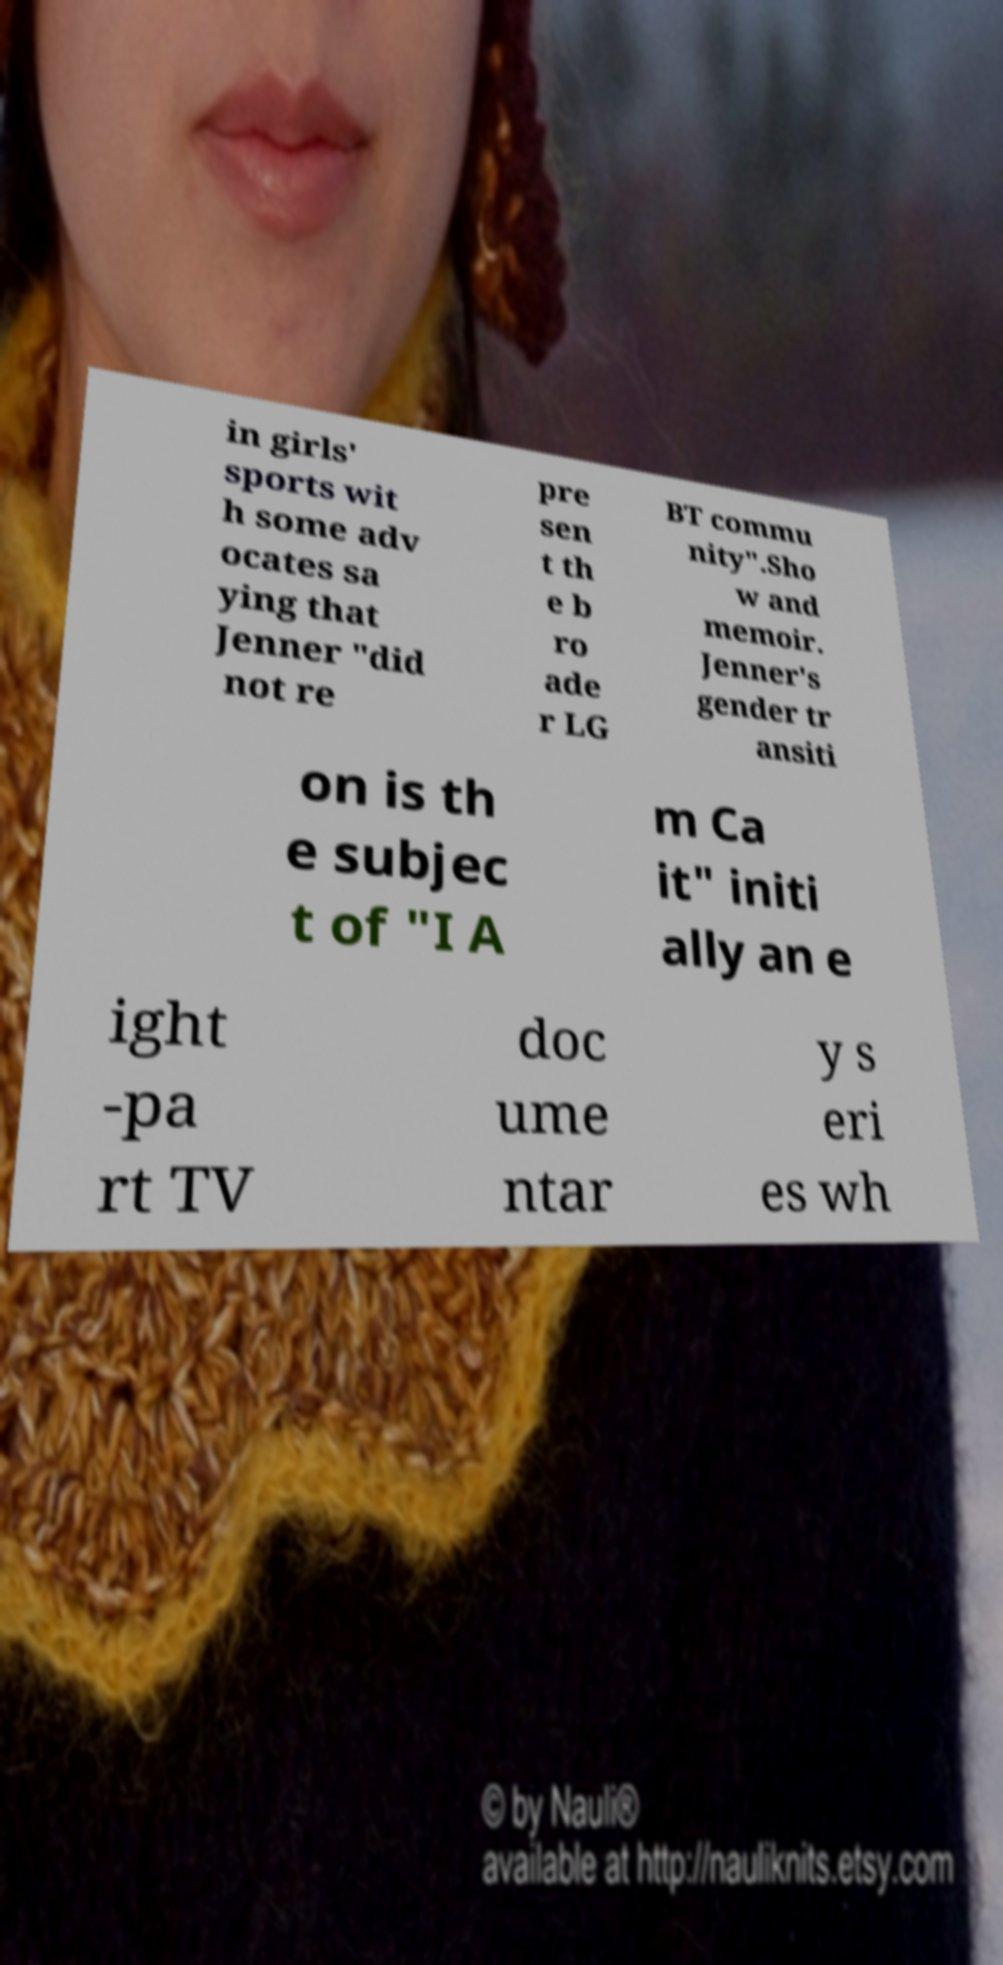Can you read and provide the text displayed in the image?This photo seems to have some interesting text. Can you extract and type it out for me? in girls' sports wit h some adv ocates sa ying that Jenner "did not re pre sen t th e b ro ade r LG BT commu nity".Sho w and memoir. Jenner's gender tr ansiti on is th e subjec t of "I A m Ca it" initi ally an e ight -pa rt TV doc ume ntar y s eri es wh 